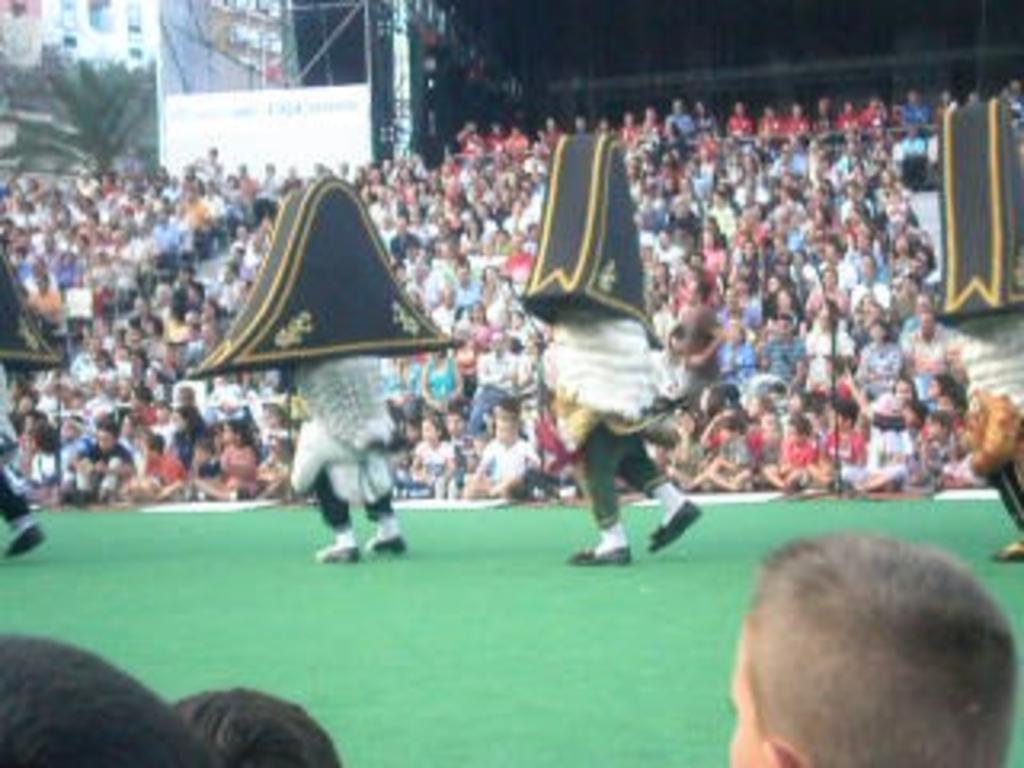How would you summarize this image in a sentence or two? In this image I can see in the middle 2 men persons are walking, they wore different things. At the back side a group of people are sitting and observing this performance on this stage. On the left side there is a tree, at the top there are buildings. 